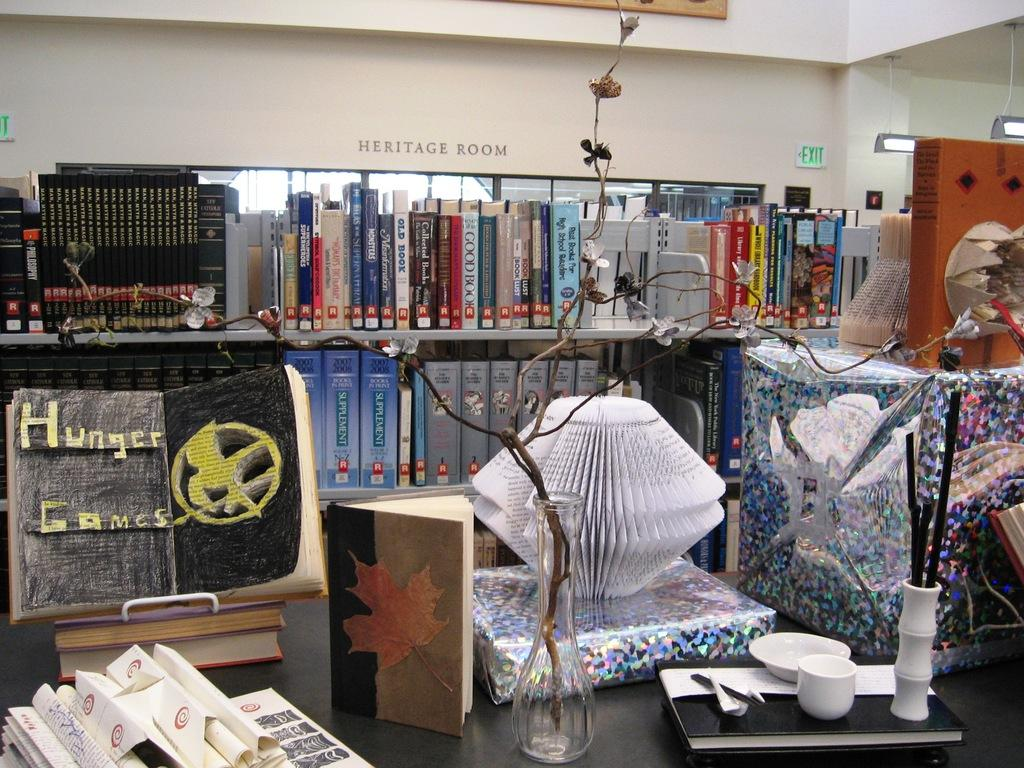<image>
Summarize the visual content of the image. A heritage room full of books with the letter R on them. 